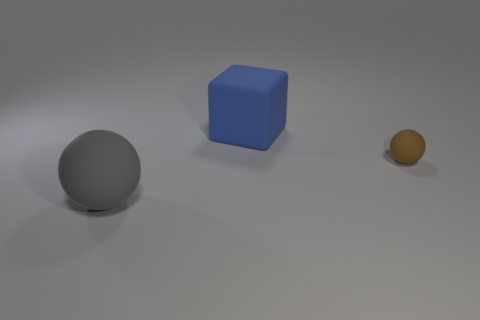Are there any other things that have the same size as the brown matte sphere?
Offer a terse response. No. What is the shape of the small object?
Make the answer very short. Sphere. What is the color of the tiny thing that is the same shape as the large gray rubber object?
Make the answer very short. Brown. There is a ball that is in front of the tiny rubber thing; what number of things are behind it?
Your answer should be compact. 2. What number of blocks are purple matte objects or tiny rubber objects?
Ensure brevity in your answer.  0. Is there a big blue rubber cylinder?
Your response must be concise. No. There is a brown thing that is the same shape as the large gray object; what is its size?
Ensure brevity in your answer.  Small. The big thing behind the matte object right of the blue rubber thing is what shape?
Keep it short and to the point. Cube. What number of blue objects are large rubber things or matte things?
Offer a very short reply. 1. What is the color of the large cube?
Offer a very short reply. Blue. 